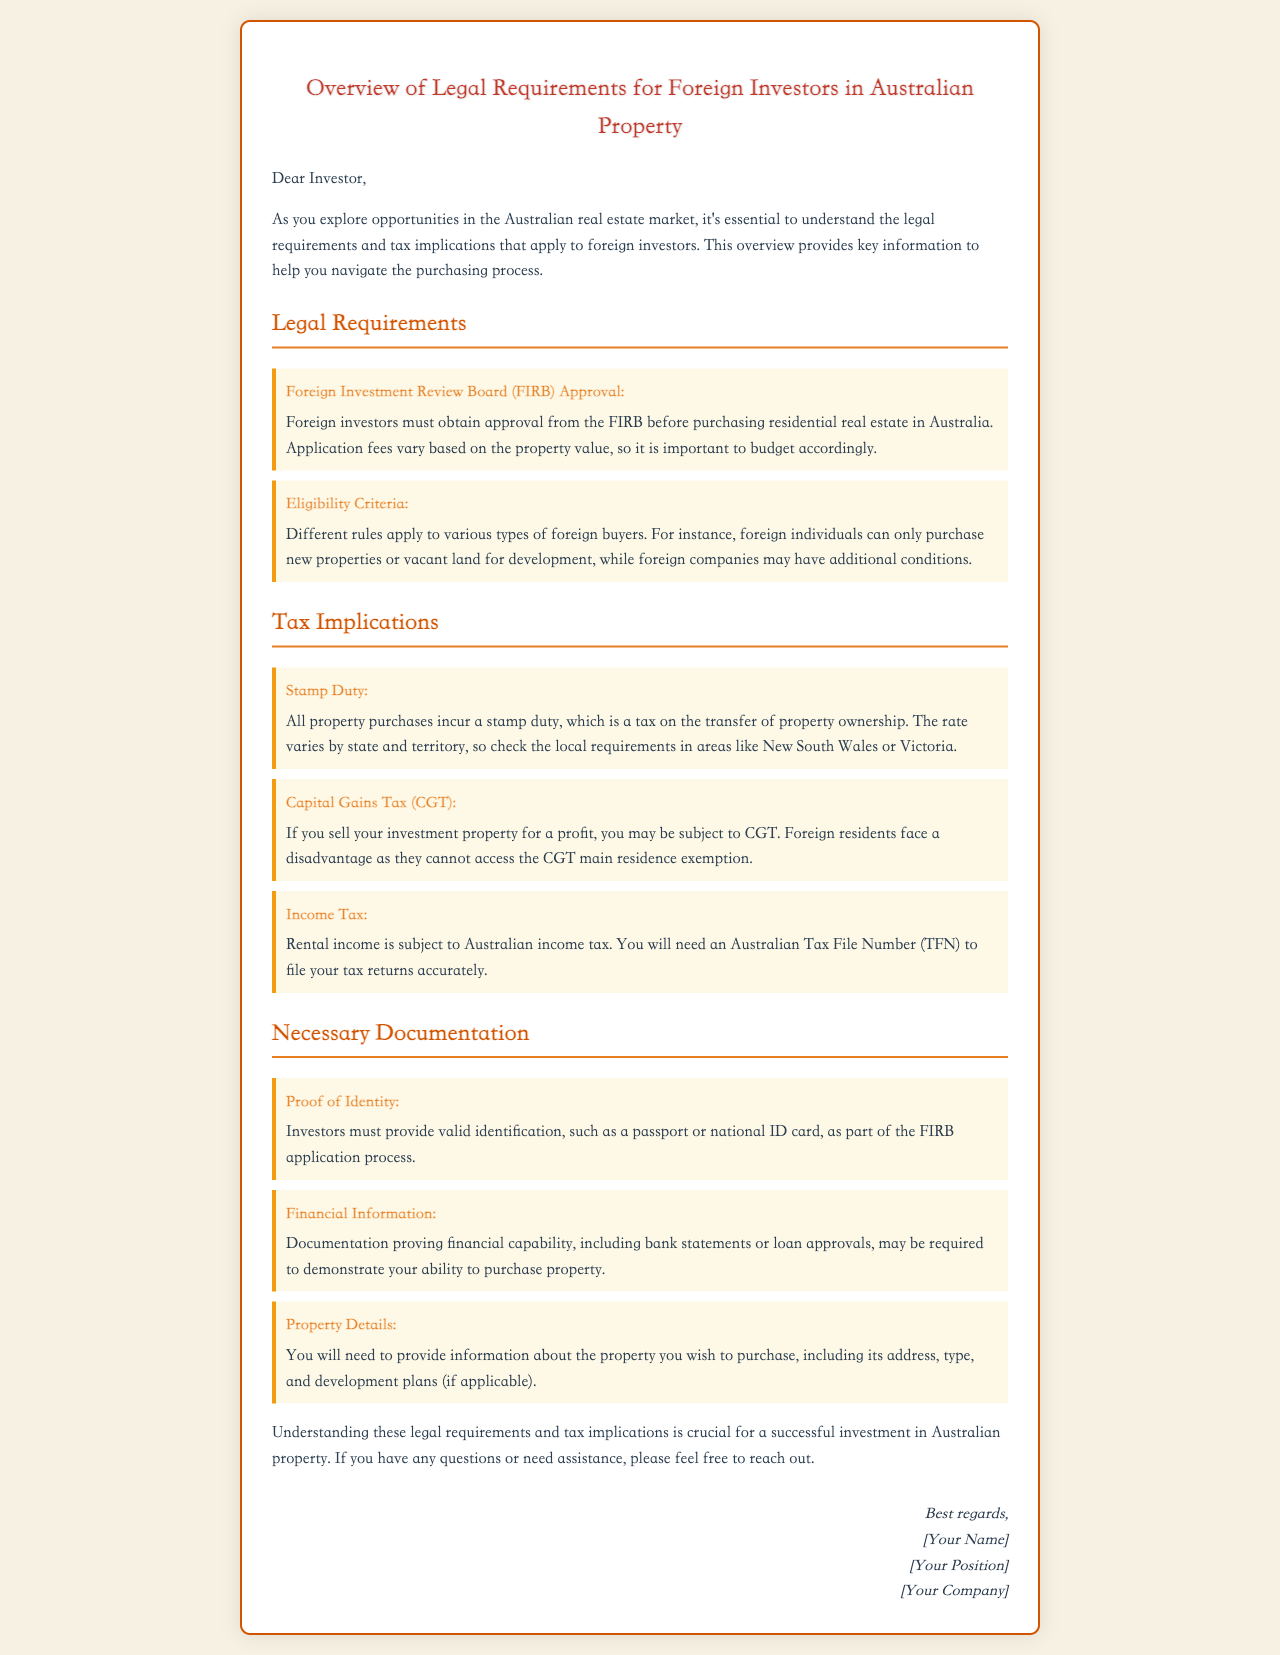What is the requirement for foreign investors before purchasing property in Australia? Foreign investors must obtain approval from the FIRB before purchasing residential real estate in Australia.
Answer: FIRB Approval What must foreign individuals purchase in Australia? Foreign individuals can only purchase new properties or vacant land for development.
Answer: New properties or vacant land What is the tax on the transfer of property ownership called? This tax is imposed on all property purchases and varies by state and territory.
Answer: Stamp Duty Which tax applies if you sell your investment property for a profit? This tax affects foreign investors and is applicable upon selling an investment property for a profit.
Answer: Capital Gains Tax What number do you need for filing tax returns in Australia? Investors will need this to accurately file their tax returns in Australia.
Answer: Australian Tax File Number What documentation is required to prove identity in the FIRB application? Investors must provide this during the FIRB application process to validate their identity.
Answer: Valid identification What kind of financial documentation is needed for property purchase capability? This includes documents that demonstrate your financial position when applying to FIRB.
Answer: Bank statements or loan approvals What is the main focus of the email? The email primarily focuses on the legal requirements and tax implications for foreign property investors.
Answer: Overview of legal requirements and tax implications What should investors do if they have questions about the requirements? The email encourages reaching out for assistance regarding any queries related to the content.
Answer: Feel free to reach out 